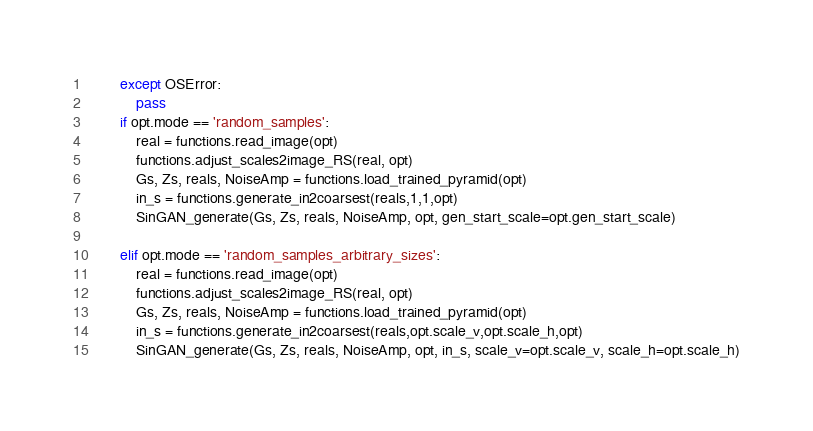Convert code to text. <code><loc_0><loc_0><loc_500><loc_500><_Python_>        except OSError:
            pass
        if opt.mode == 'random_samples':
            real = functions.read_image(opt)
            functions.adjust_scales2image_RS(real, opt)
            Gs, Zs, reals, NoiseAmp = functions.load_trained_pyramid(opt)
            in_s = functions.generate_in2coarsest(reals,1,1,opt)
            SinGAN_generate(Gs, Zs, reals, NoiseAmp, opt, gen_start_scale=opt.gen_start_scale)

        elif opt.mode == 'random_samples_arbitrary_sizes':
            real = functions.read_image(opt)
            functions.adjust_scales2image_RS(real, opt)
            Gs, Zs, reals, NoiseAmp = functions.load_trained_pyramid(opt)
            in_s = functions.generate_in2coarsest(reals,opt.scale_v,opt.scale_h,opt)
            SinGAN_generate(Gs, Zs, reals, NoiseAmp, opt, in_s, scale_v=opt.scale_v, scale_h=opt.scale_h)





</code> 